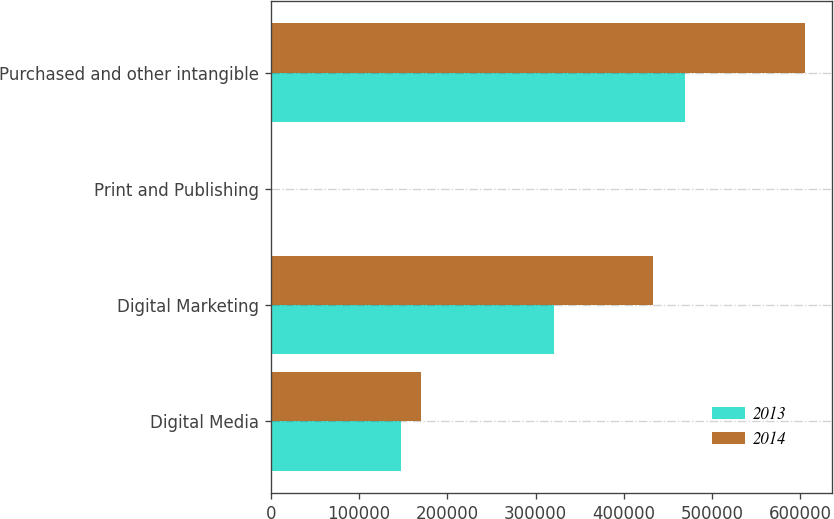<chart> <loc_0><loc_0><loc_500><loc_500><stacked_bar_chart><ecel><fcel>Digital Media<fcel>Digital Marketing<fcel>Print and Publishing<fcel>Purchased and other intangible<nl><fcel>2013<fcel>147182<fcel>321086<fcel>1394<fcel>469662<nl><fcel>2014<fcel>170213<fcel>433245<fcel>1796<fcel>605254<nl></chart> 